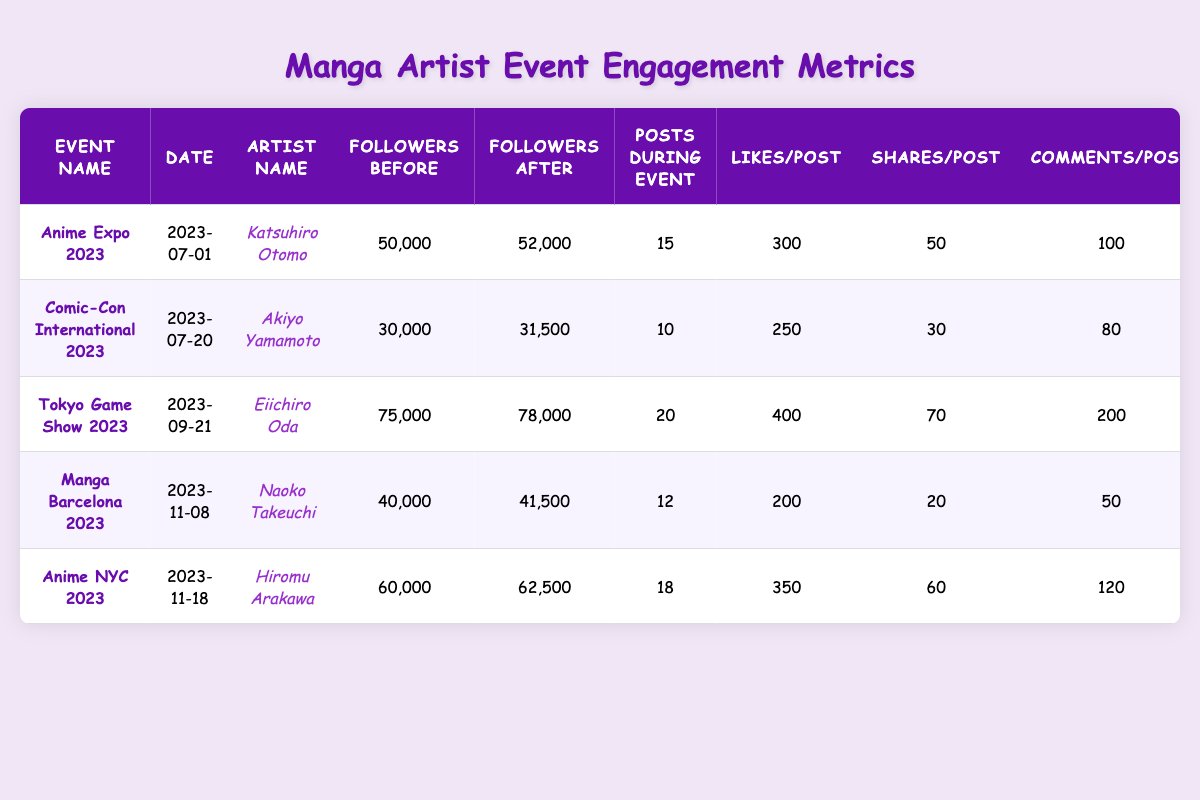What is the engagement rate for Katsuhiro Otomo at Anime Expo 2023? The engagement rate is listed in the table as 4.5% for Katsuhiro Otomo during Anime Expo 2023.
Answer: 4.5% How many new followers did Eiichiro Oda gain at the Tokyo Game Show 2023? The table shows that Eiichiro Oda gained 3000 new followers at the Tokyo Game Show 2023.
Answer: 3000 Which event had the highest number of posts during the event? The table indicates that Tokyo Game Show 2023 had the highest number of posts during the event with 20 posts.
Answer: Tokyo Game Show 2023 What is the difference in followers before and after the event for Naoko Takeuchi at Manga Barcelona 2023? Naoko Takeuchi had 40000 followers before and 41500 after the event, so the difference is 41500 - 40000 = 1500.
Answer: 1500 How many total likes did Hiromu Arakawa receive during Anime NYC 2023? Hiromu Arakawa made 18 posts with an average of 350 likes per post, so total likes = 18 * 350 = 6300.
Answer: 6300 What percentage of new followers did Akiyo Yamamoto gain compared to his followers before the event at Comic-Con International 2023? Akiyo Yamamoto gained 1500 new followers from 30000 before the event, so the percentage is (1500 / 30000) * 100 = 5%.
Answer: 5% Which artist had the lowest engagement rate and what was it? The lowest engagement rate is for Naoko Takeuchi at Manga Barcelona 2023, with an engagement rate of 3.2%.
Answer: 3.2% If we consider the average likes per post across all events, what is it? The total likes from all events are (300 * 15) + (250 * 10) + (400 * 20) + (200 * 12) + (350 * 18) = 4500 + 2500 + 8000 + 2400 + 6300 = 23700. The total number of posts is 15 + 10 + 20 + 12 + 18 = 85, so average likes per post = 23700 / 85 ≈ 278.82.
Answer: 278.82 Did any artist gain a higher engagement rate than 4.5%? Yes, Eiichiro Oda at Tokyo Game Show 2023 had an engagement rate of 5.0%, which is higher than 4.5%.
Answer: Yes What is the total increase in followers after all events listed? The total new followers gained from all events are 2000 + 1500 + 3000 + 1500 + 2500 = 10500.
Answer: 10500 